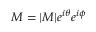Convert formula to latex. <formula><loc_0><loc_0><loc_500><loc_500>M = | M | e ^ { i \theta } e ^ { i \phi }</formula> 